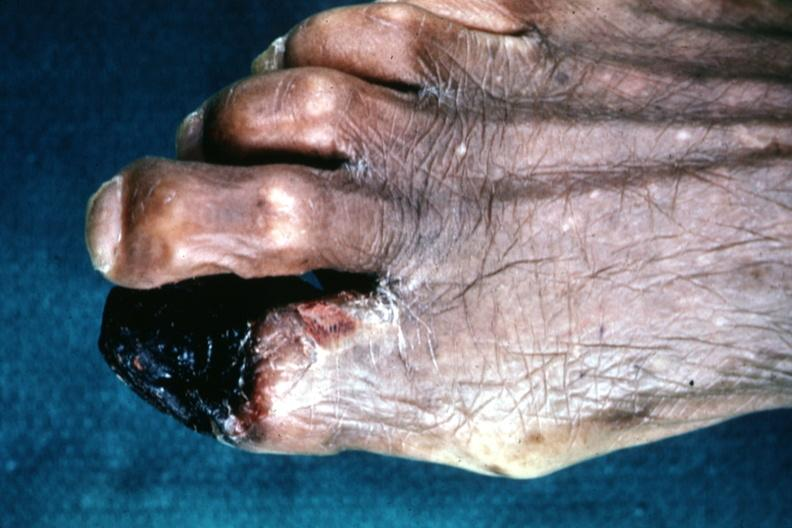s gangrene present?
Answer the question using a single word or phrase. Yes 